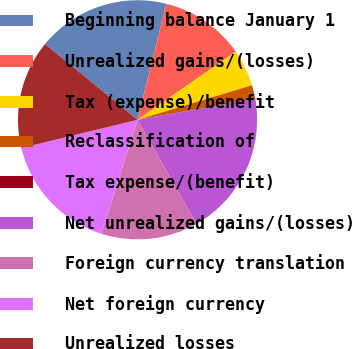Convert chart to OTSL. <chart><loc_0><loc_0><loc_500><loc_500><pie_chart><fcel>Beginning balance January 1<fcel>Unrealized gains/(losses)<fcel>Tax (expense)/benefit<fcel>Reclassification of<fcel>Tax expense/(benefit)<fcel>Net unrealized gains/(losses)<fcel>Foreign currency translation<fcel>Net foreign currency<fcel>Unrealized losses<nl><fcel>17.95%<fcel>11.47%<fcel>4.99%<fcel>1.75%<fcel>0.13%<fcel>19.57%<fcel>13.09%<fcel>16.33%<fcel>14.71%<nl></chart> 